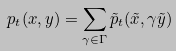<formula> <loc_0><loc_0><loc_500><loc_500>p _ { t } ( x , y ) = \sum _ { \gamma \in \Gamma } \tilde { p } _ { t } ( \tilde { x } , \gamma \tilde { y } )</formula> 